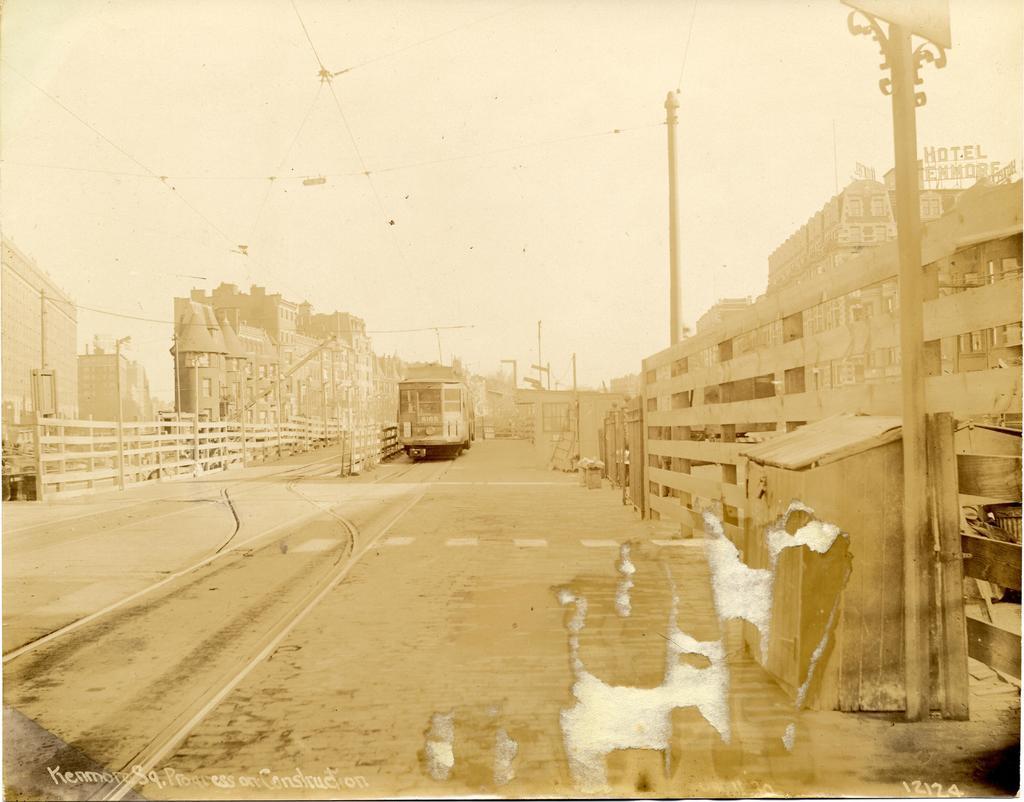Describe this image in one or two sentences. In this image on the right side there is one box and at the bottom there is a road, on the road there is one bus and in the background there are some buildings, poles and street lights. On the top of the image there are some wires and sky. 